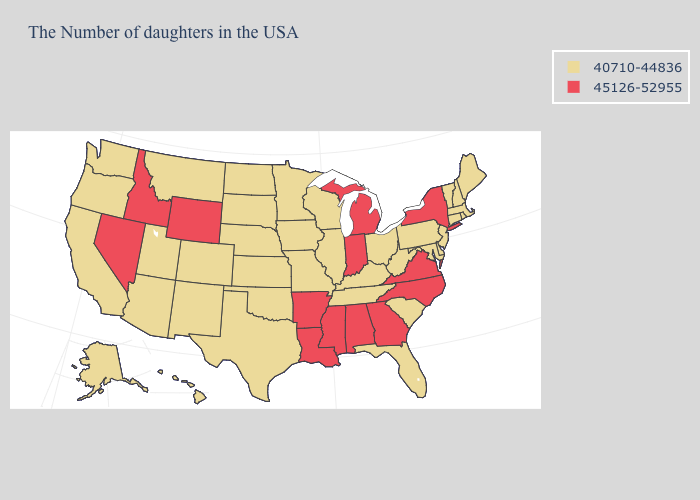What is the highest value in states that border Kansas?
Answer briefly. 40710-44836. Name the states that have a value in the range 40710-44836?
Write a very short answer. Maine, Massachusetts, Rhode Island, New Hampshire, Vermont, Connecticut, New Jersey, Delaware, Maryland, Pennsylvania, South Carolina, West Virginia, Ohio, Florida, Kentucky, Tennessee, Wisconsin, Illinois, Missouri, Minnesota, Iowa, Kansas, Nebraska, Oklahoma, Texas, South Dakota, North Dakota, Colorado, New Mexico, Utah, Montana, Arizona, California, Washington, Oregon, Alaska, Hawaii. Name the states that have a value in the range 45126-52955?
Be succinct. New York, Virginia, North Carolina, Georgia, Michigan, Indiana, Alabama, Mississippi, Louisiana, Arkansas, Wyoming, Idaho, Nevada. What is the value of Oklahoma?
Concise answer only. 40710-44836. Name the states that have a value in the range 45126-52955?
Concise answer only. New York, Virginia, North Carolina, Georgia, Michigan, Indiana, Alabama, Mississippi, Louisiana, Arkansas, Wyoming, Idaho, Nevada. What is the value of Kansas?
Be succinct. 40710-44836. What is the lowest value in the South?
Give a very brief answer. 40710-44836. Name the states that have a value in the range 45126-52955?
Quick response, please. New York, Virginia, North Carolina, Georgia, Michigan, Indiana, Alabama, Mississippi, Louisiana, Arkansas, Wyoming, Idaho, Nevada. What is the value of Wisconsin?
Concise answer only. 40710-44836. Name the states that have a value in the range 40710-44836?
Give a very brief answer. Maine, Massachusetts, Rhode Island, New Hampshire, Vermont, Connecticut, New Jersey, Delaware, Maryland, Pennsylvania, South Carolina, West Virginia, Ohio, Florida, Kentucky, Tennessee, Wisconsin, Illinois, Missouri, Minnesota, Iowa, Kansas, Nebraska, Oklahoma, Texas, South Dakota, North Dakota, Colorado, New Mexico, Utah, Montana, Arizona, California, Washington, Oregon, Alaska, Hawaii. Among the states that border Pennsylvania , does West Virginia have the highest value?
Be succinct. No. What is the value of Kentucky?
Be succinct. 40710-44836. Does Arkansas have the highest value in the USA?
Short answer required. Yes. Does the map have missing data?
Short answer required. No. What is the value of North Carolina?
Answer briefly. 45126-52955. 